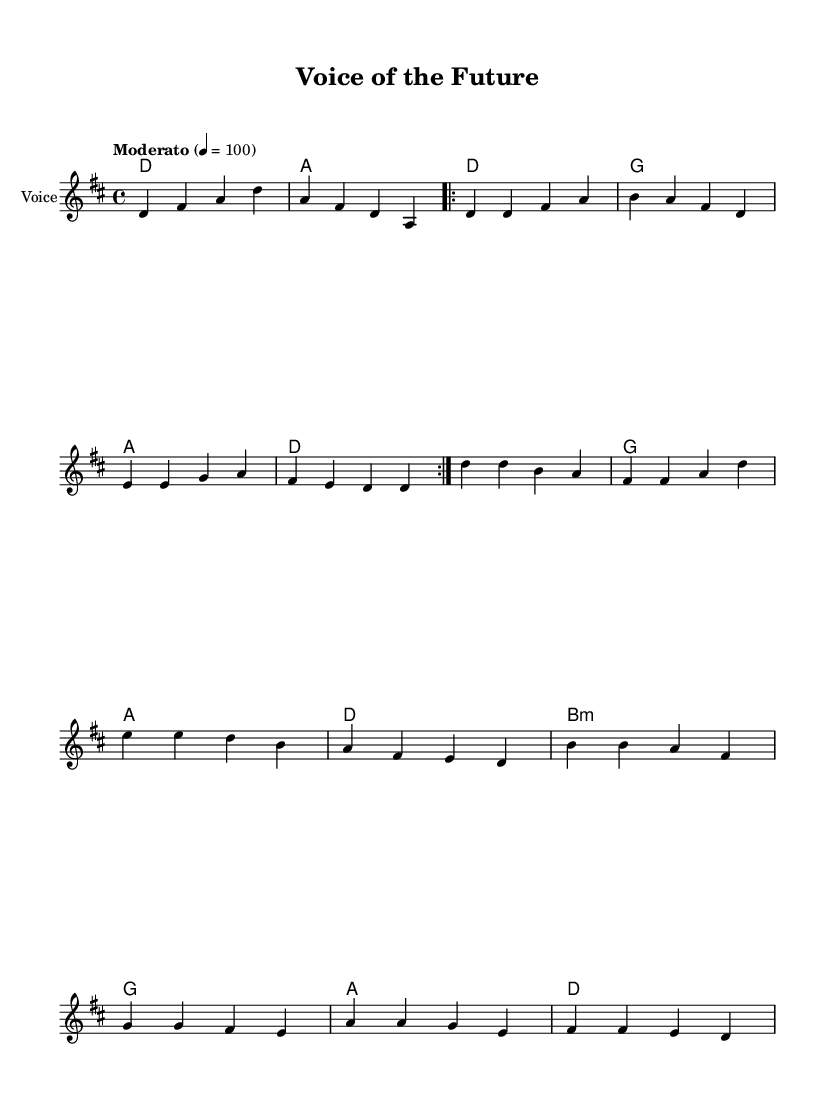What is the key signature of this music? The key signature is D major, which has two sharps (F# and C#). This can be identified by looking at the key signature indicated at the beginning of the staff.
Answer: D major What is the time signature of this music? The time signature is 4/4, which means there are four beats per measure and the quarter note gets one beat. This is visible at the start of the sheet music where the time signature is marked.
Answer: 4/4 What is the tempo marking of this music? The tempo marking is "Moderato," which indicates a moderate speed of the piece. This can be found near the top of the sheet music where the tempo is stated.
Answer: Moderato How many measures are in the verse section? The verse section has eight measures, as determined by counting the measures in the specified verse section in the melody part.
Answer: Eight What chord follows the first measure of the chorus? The chord following the first measure of the chorus is G major. This can be found in the harmonies under the chorus section where the chord is explicitly indicated after the first measure.
Answer: G What is the primary theme of the lyrics? The primary theme of the lyrics focuses on empowerment and education. By examining the lyrics encapsulated under the melody, one can determine the concept of raising voices and standing up for change which is the core message.
Answer: Empowerment What type of song is this considered? This song is considered contemporary folk, characterized by its narrative lyrics about student activism and youth empowerment along with its acoustic musical elements. This is inferred from the style and typical themes presented in folk music.
Answer: Contemporary folk 